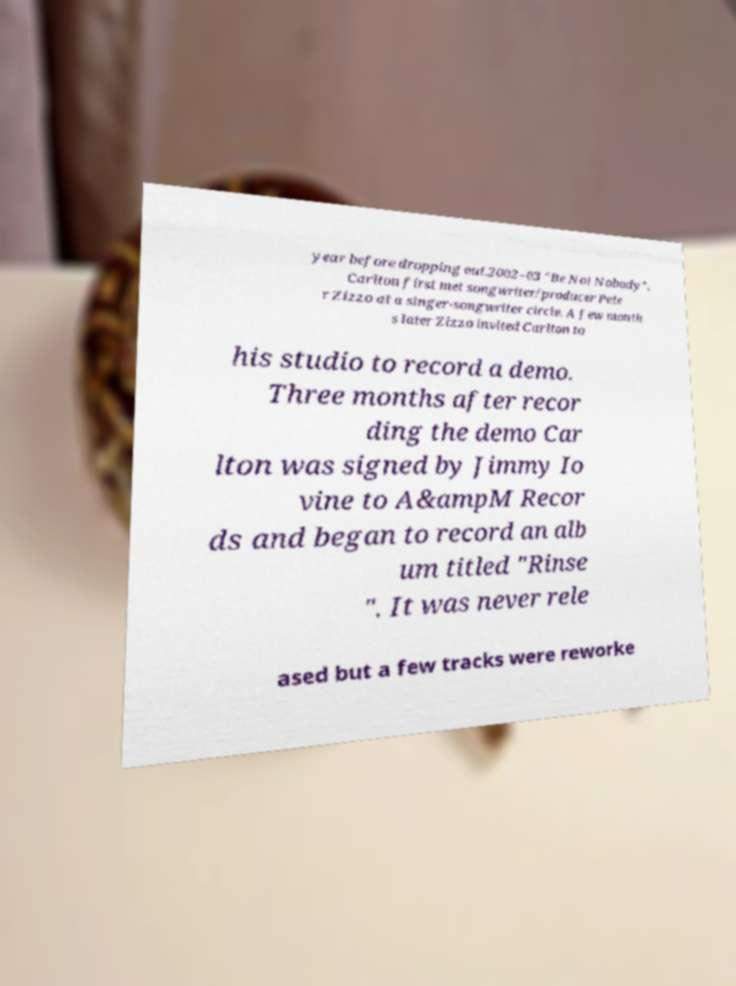Can you accurately transcribe the text from the provided image for me? year before dropping out.2002–03 "Be Not Nobody". Carlton first met songwriter/producer Pete r Zizzo at a singer-songwriter circle. A few month s later Zizzo invited Carlton to his studio to record a demo. Three months after recor ding the demo Car lton was signed by Jimmy Io vine to A&ampM Recor ds and began to record an alb um titled "Rinse ". It was never rele ased but a few tracks were reworke 